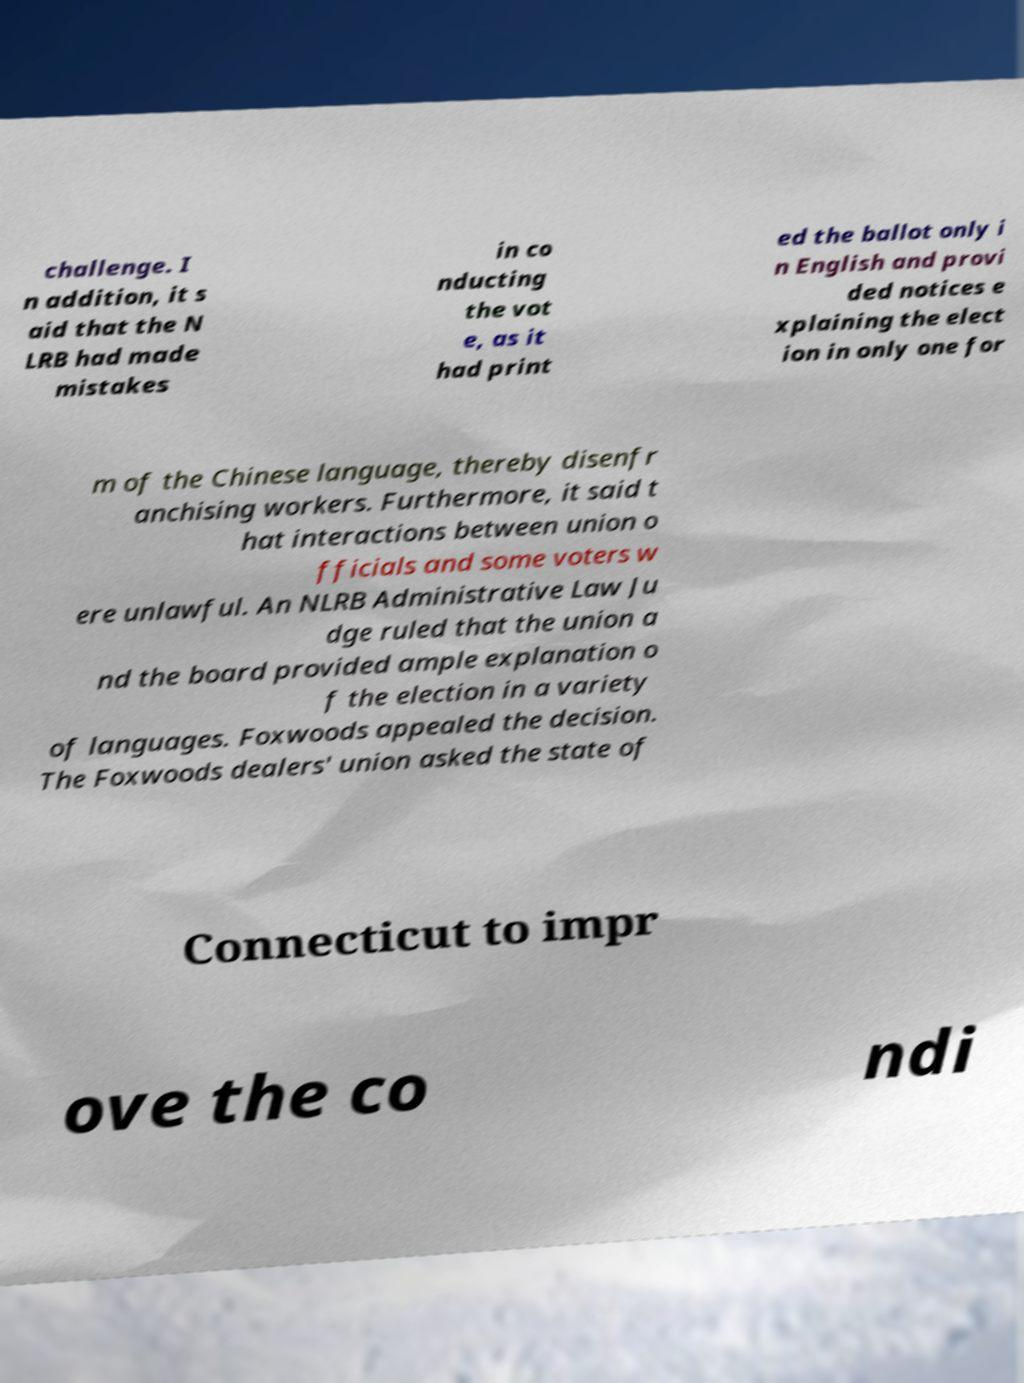Please read and relay the text visible in this image. What does it say? challenge. I n addition, it s aid that the N LRB had made mistakes in co nducting the vot e, as it had print ed the ballot only i n English and provi ded notices e xplaining the elect ion in only one for m of the Chinese language, thereby disenfr anchising workers. Furthermore, it said t hat interactions between union o fficials and some voters w ere unlawful. An NLRB Administrative Law Ju dge ruled that the union a nd the board provided ample explanation o f the election in a variety of languages. Foxwoods appealed the decision. The Foxwoods dealers' union asked the state of Connecticut to impr ove the co ndi 